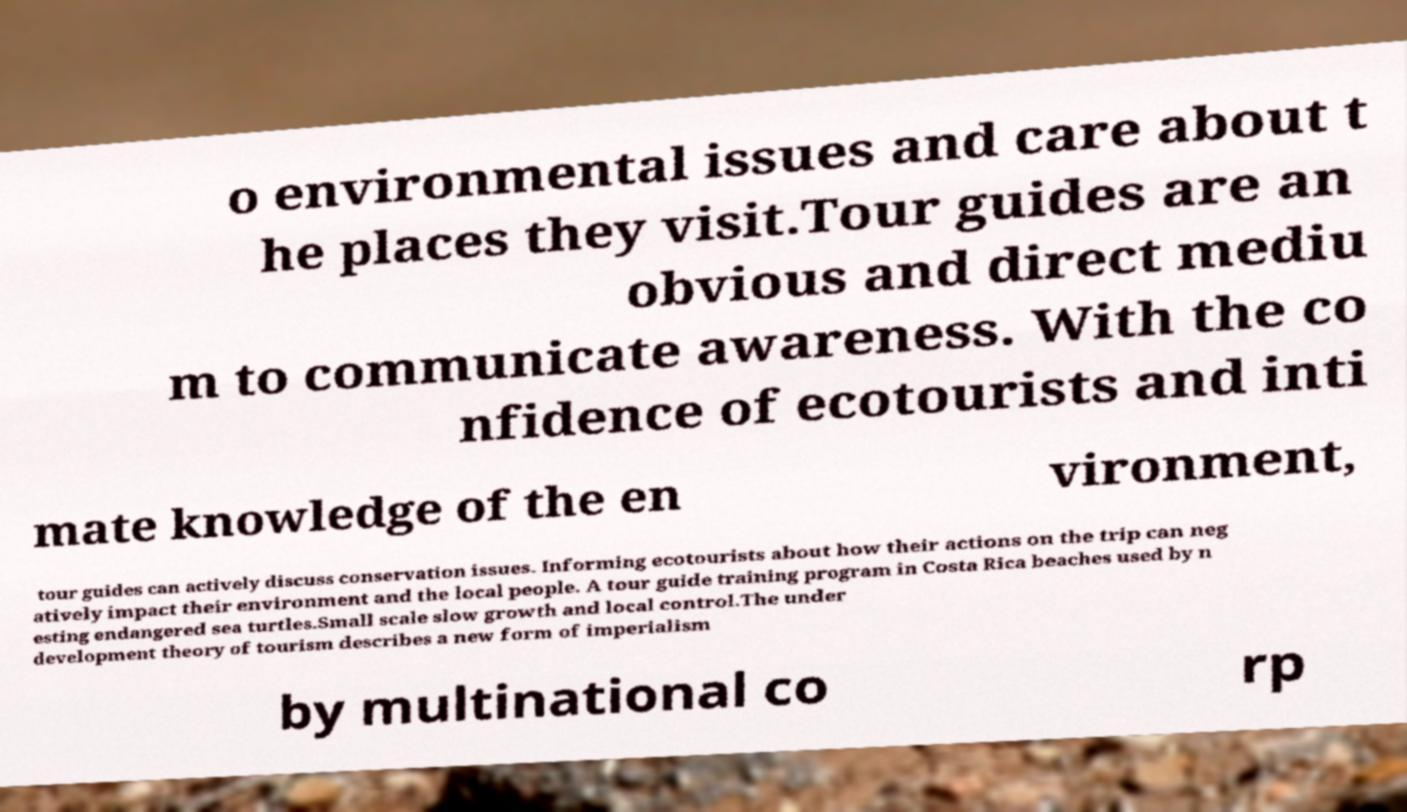Can you read and provide the text displayed in the image?This photo seems to have some interesting text. Can you extract and type it out for me? o environmental issues and care about t he places they visit.Tour guides are an obvious and direct mediu m to communicate awareness. With the co nfidence of ecotourists and inti mate knowledge of the en vironment, tour guides can actively discuss conservation issues. Informing ecotourists about how their actions on the trip can neg atively impact their environment and the local people. A tour guide training program in Costa Rica beaches used by n esting endangered sea turtles.Small scale slow growth and local control.The under development theory of tourism describes a new form of imperialism by multinational co rp 